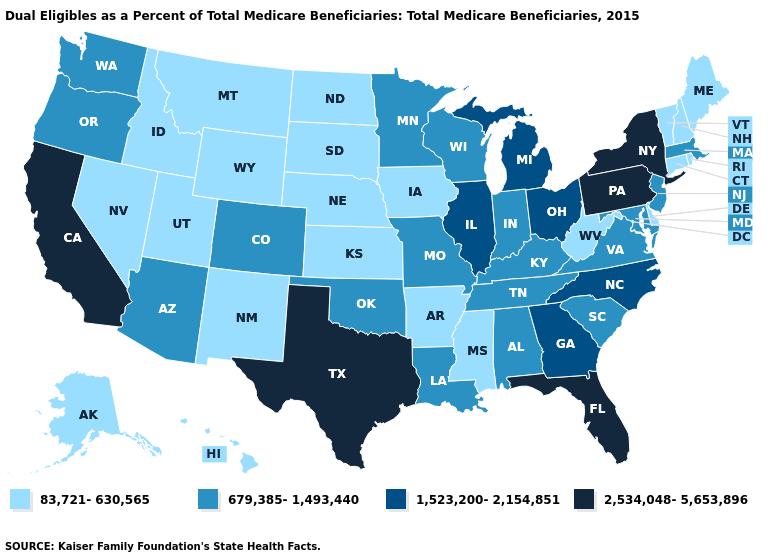Does Florida have the lowest value in the South?
Give a very brief answer. No. Name the states that have a value in the range 1,523,200-2,154,851?
Be succinct. Georgia, Illinois, Michigan, North Carolina, Ohio. Name the states that have a value in the range 679,385-1,493,440?
Be succinct. Alabama, Arizona, Colorado, Indiana, Kentucky, Louisiana, Maryland, Massachusetts, Minnesota, Missouri, New Jersey, Oklahoma, Oregon, South Carolina, Tennessee, Virginia, Washington, Wisconsin. Is the legend a continuous bar?
Concise answer only. No. Among the states that border Arizona , does New Mexico have the highest value?
Be succinct. No. Name the states that have a value in the range 2,534,048-5,653,896?
Give a very brief answer. California, Florida, New York, Pennsylvania, Texas. What is the lowest value in the South?
Be succinct. 83,721-630,565. Name the states that have a value in the range 1,523,200-2,154,851?
Quick response, please. Georgia, Illinois, Michigan, North Carolina, Ohio. What is the value of Maryland?
Give a very brief answer. 679,385-1,493,440. What is the value of Georgia?
Keep it brief. 1,523,200-2,154,851. Does Oklahoma have a higher value than Rhode Island?
Quick response, please. Yes. Does Massachusetts have a higher value than Rhode Island?
Short answer required. Yes. What is the highest value in the USA?
Write a very short answer. 2,534,048-5,653,896. Which states have the lowest value in the USA?
Keep it brief. Alaska, Arkansas, Connecticut, Delaware, Hawaii, Idaho, Iowa, Kansas, Maine, Mississippi, Montana, Nebraska, Nevada, New Hampshire, New Mexico, North Dakota, Rhode Island, South Dakota, Utah, Vermont, West Virginia, Wyoming. 